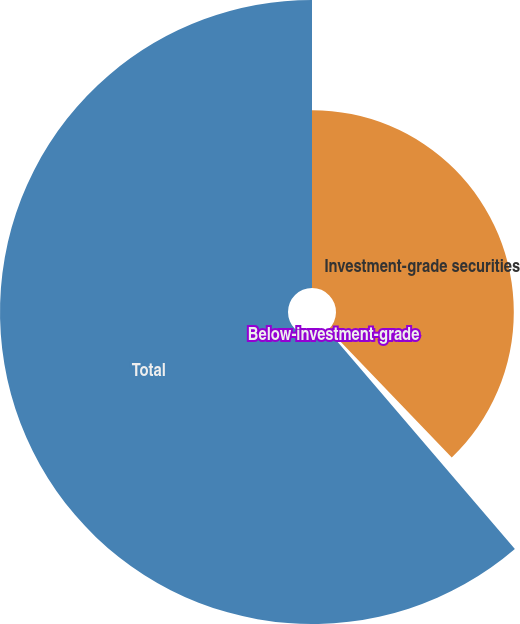<chart> <loc_0><loc_0><loc_500><loc_500><pie_chart><fcel>Investment-grade securities<fcel>Below-investment-grade<fcel>Total<nl><fcel>37.82%<fcel>0.91%<fcel>61.26%<nl></chart> 